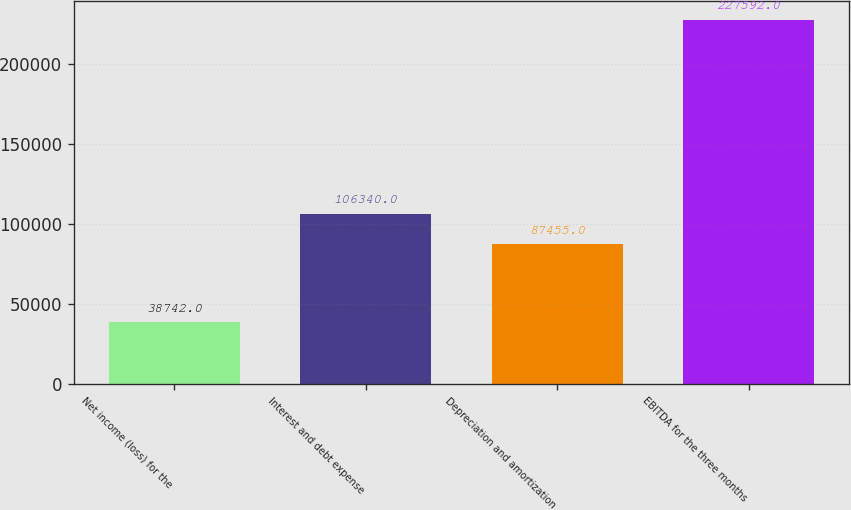<chart> <loc_0><loc_0><loc_500><loc_500><bar_chart><fcel>Net income (loss) for the<fcel>Interest and debt expense<fcel>Depreciation and amortization<fcel>EBITDA for the three months<nl><fcel>38742<fcel>106340<fcel>87455<fcel>227592<nl></chart> 